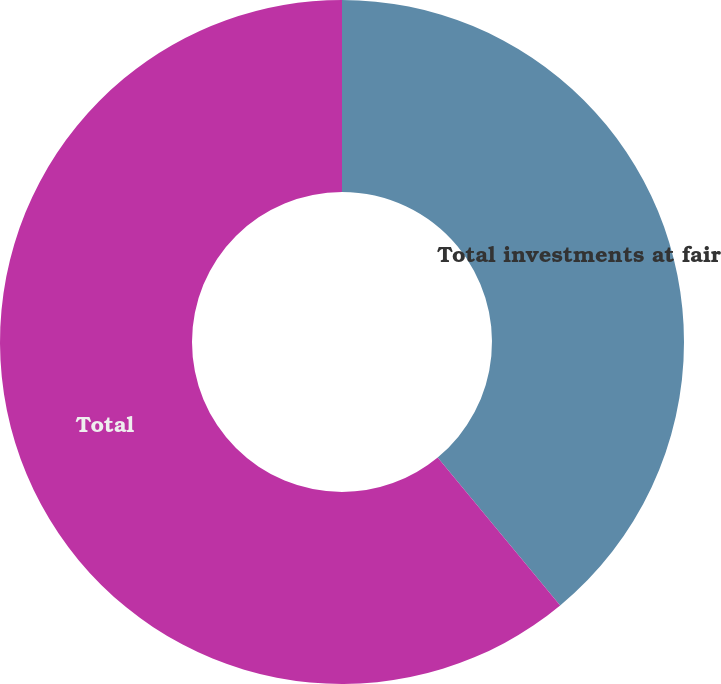Convert chart. <chart><loc_0><loc_0><loc_500><loc_500><pie_chart><fcel>Total investments at fair<fcel>Total<nl><fcel>38.99%<fcel>61.01%<nl></chart> 